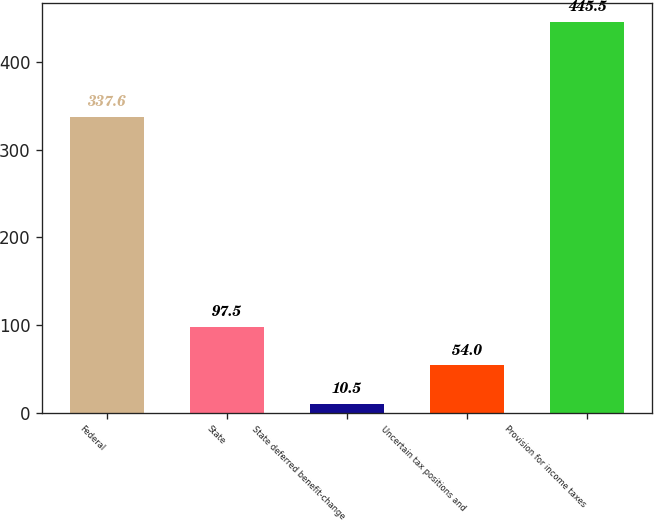<chart> <loc_0><loc_0><loc_500><loc_500><bar_chart><fcel>Federal<fcel>State<fcel>State deferred benefit-change<fcel>Uncertain tax positions and<fcel>Provision for income taxes<nl><fcel>337.6<fcel>97.5<fcel>10.5<fcel>54<fcel>445.5<nl></chart> 